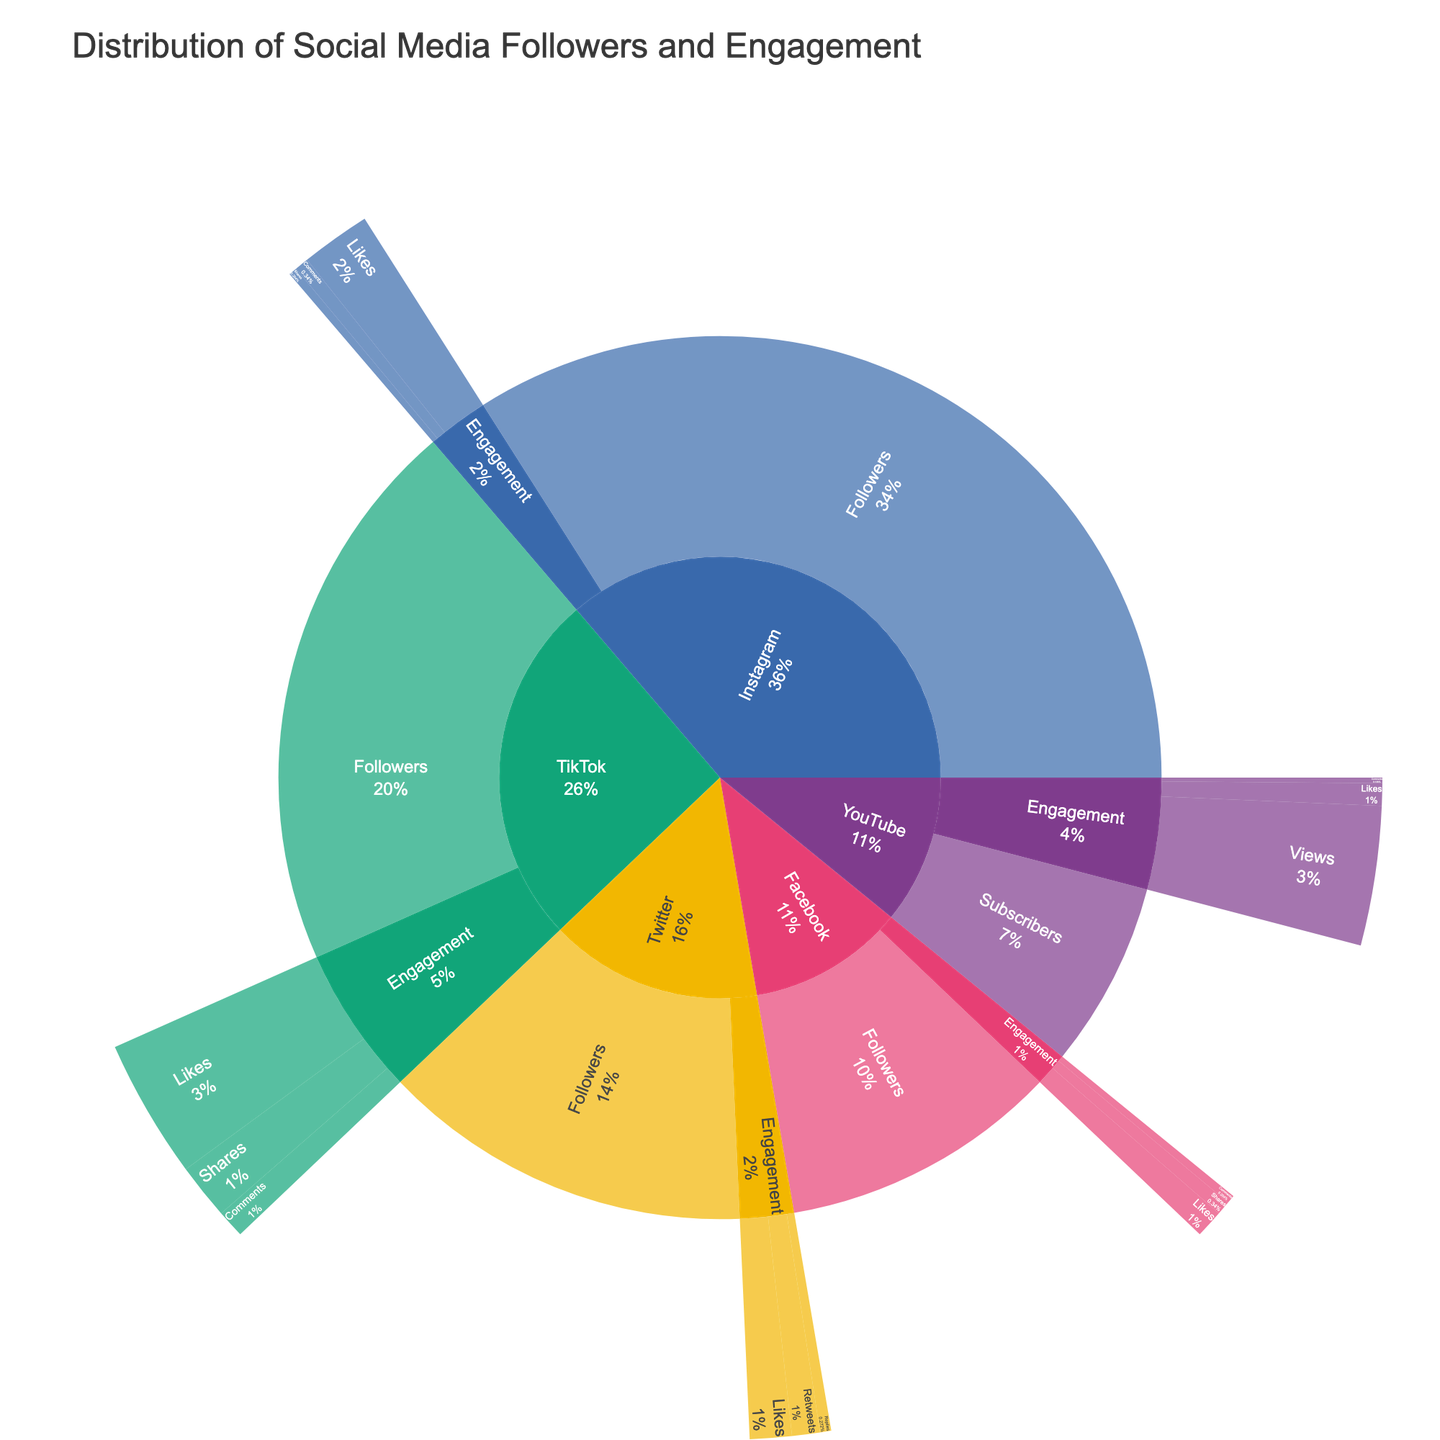what's the largest value for a social media platform? The sunburst plot shows the distribution of followers and engagement levels across social media platforms. By analyzing the outer rings, Instagram's followers have the largest segment with a value of 5,000,000.
Answer: 5,000,000 Which platform has the highest number of total engagements? Total engagements include all forms of interactions like likes, comments, shares, etc. Summarizing the engagement values for each platform: Instagram (250,000+50,000+30,000), Twitter (150,000+100,000+40,000), TikTok (500,000+100,000+200,000), YouTube (500,000+80,000+20,000), Facebook (100,000+30,000+50,000). TikTok has the highest total engagements with 800,000 (500,000+100,000+200,000).
Answer: TikTok How do Twitter's likes compare to Instagram's likes? The sunburst plot displays the engagement levels under each platform. Comparing the likes: Twitter has 150,000 likes whereas Instagram has 250,000 likes. Therefore, Instagram has more likes than Twitter.
Answer: Instagram has more likes than Twitter What social media platform has the smallest user base in terms of followers/subscribers? By examining the initial layer of the sunburst plot, the platform with the smallest segment is YouTube, which has 1,000,000 subscribers.
Answer: YouTube What percentage of Instagram's total followers are engaged through comments? First, identify Instagram's comments segment value (50,000) and its total followers (5,000,000). The percentage is calculated as (50,000 / 5,000,000) * 100 = 1%.
Answer: 1% How many total followers are there across all platforms? Summarize the total followers from each platform (Instagram: 5,000,000, Twitter: 2,000,000, TikTok: 3,000,000, YouTube: 1,000,000, Facebook: 1,500,000). Adding them gives 12,500,000.
Answer: 12,500,000 Which social media platform has the highest engagement in shares? The sunburst plot shows engagement levels including shares for each platform. Analyzing the share values: Instagram (30,000), Twitter (none), TikTok (200,000), YouTube (none), and Facebook (50,000). TikTok leads with 200,000 shares.
Answer: TikTok Is the number of TikTok's likes greater than Facebook's total engagement? TikTok has 500,000 likes. To find Facebook's total engagement, sum its interaction values (likes: 100,000 + comments: 30,000 + shares: 50,000) which equals 180,000. Since 500,000 likes is greater than 180,000, TikTok's likes are greater.
Answer: Yes Which platform has more comments: YouTube or TikTok? Comparing the segments of comments for each: YouTube has 20,000 comments and TikTok has 100,000 comments. Therefore, TikTok has more comments.
Answer: TikTok 